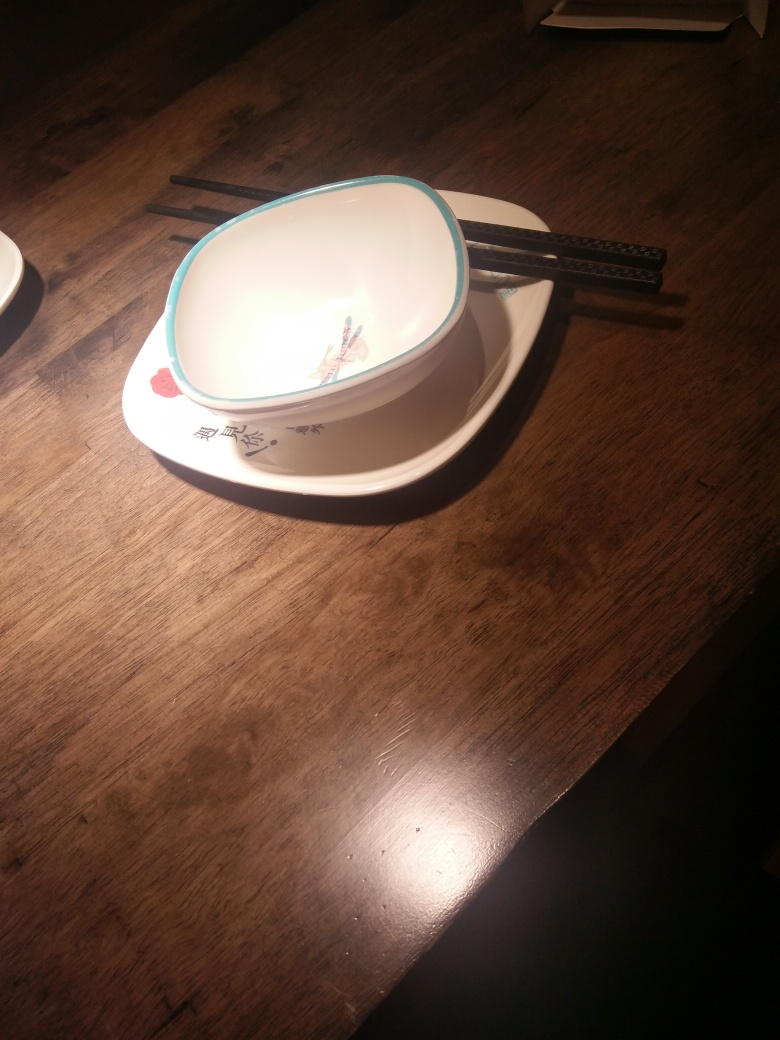What can you tell about the surface the dish is placed on? The dish is resting on a richly toned wooden surface, which shows grain patterns characteristic of a finished wood table or countertop, adding a natural and rustic element to the setting. 